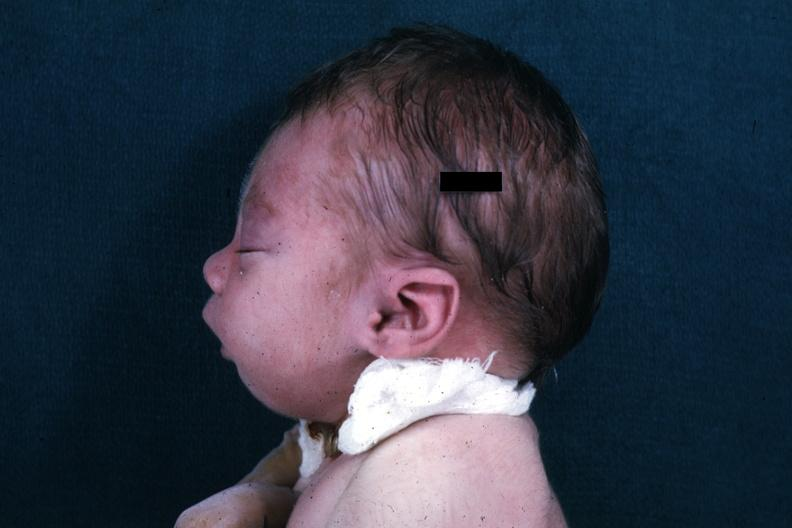do liver with tuberculoid granuloma in glissons head showing mandibular lesion?
Answer the question using a single word or phrase. No 